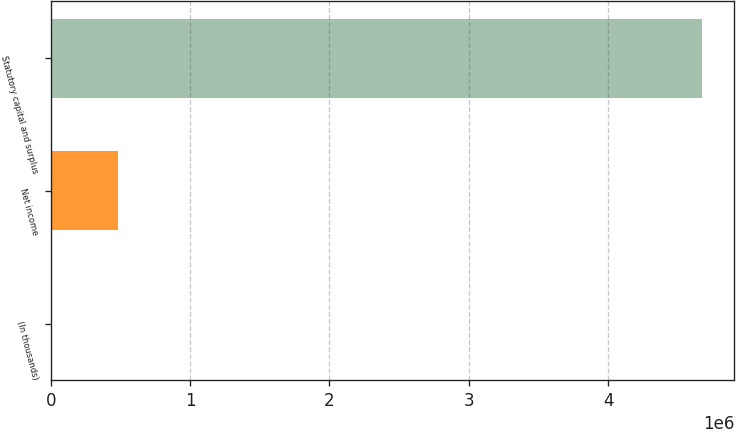Convert chart. <chart><loc_0><loc_0><loc_500><loc_500><bar_chart><fcel>(In thousands)<fcel>Net income<fcel>Statutory capital and surplus<nl><fcel>2012<fcel>482457<fcel>4.67198e+06<nl></chart> 